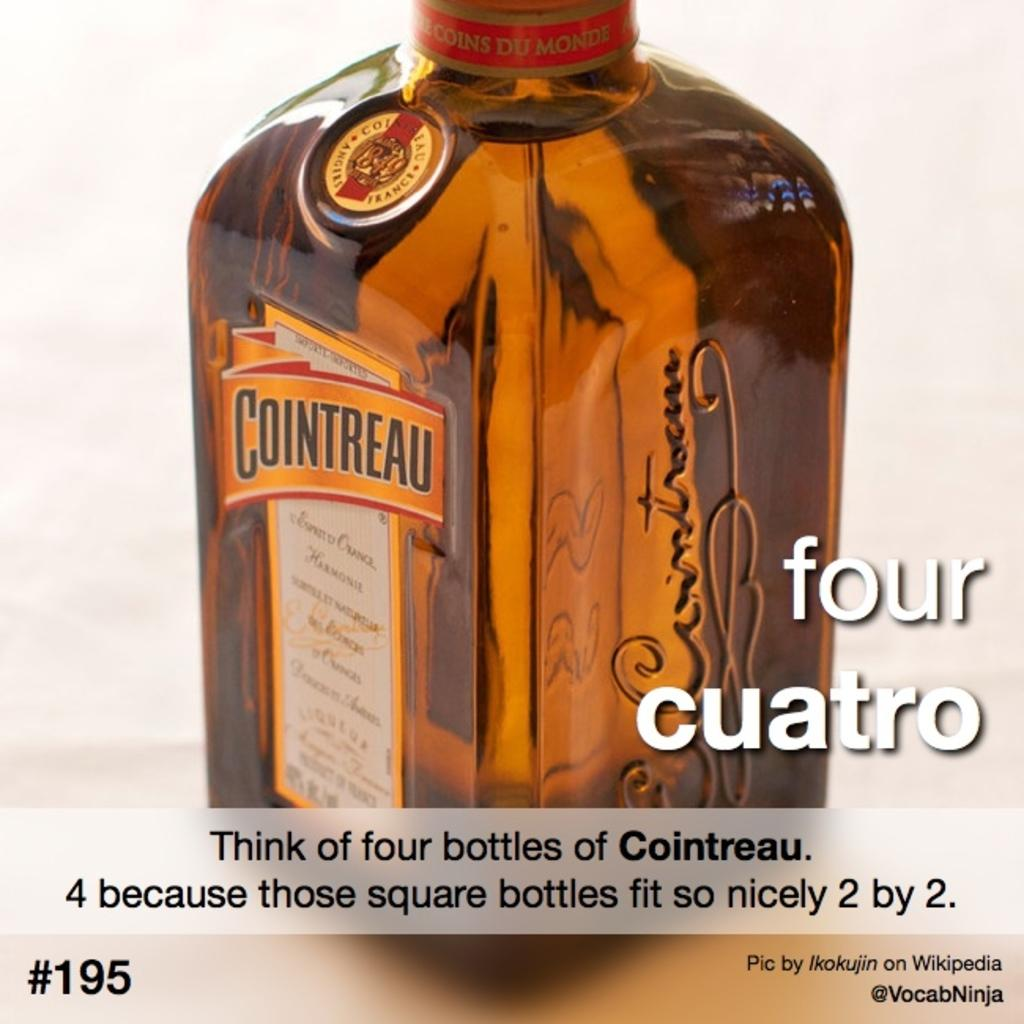<image>
Write a terse but informative summary of the picture. A bottle of Cointreau has a gold and red label. 